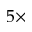<formula> <loc_0><loc_0><loc_500><loc_500>5 \times</formula> 